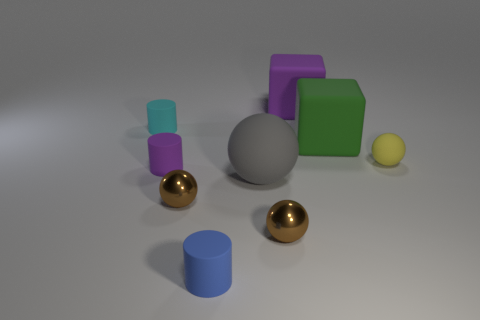There is a tiny sphere that is to the right of the matte block that is in front of the purple matte cube; what color is it?
Your answer should be compact. Yellow. How many large rubber objects are both to the right of the gray rubber ball and in front of the yellow ball?
Offer a terse response. 0. What number of gray matte objects have the same shape as the yellow thing?
Your answer should be compact. 1. Does the large green object have the same material as the big purple block?
Make the answer very short. Yes. There is a small matte object that is to the right of the cube that is in front of the tiny cyan rubber thing; what is its shape?
Offer a very short reply. Sphere. How many small matte balls are behind the yellow sphere that is behind the small purple rubber thing?
Ensure brevity in your answer.  0. What is the tiny sphere that is right of the big sphere and left of the purple rubber block made of?
Offer a very short reply. Metal. What shape is the cyan thing that is the same size as the yellow thing?
Give a very brief answer. Cylinder. There is a small metallic ball that is on the right side of the matte ball that is to the left of the tiny ball that is on the right side of the large purple matte object; what color is it?
Provide a succinct answer. Brown. How many objects are tiny matte objects that are behind the large green block or purple cylinders?
Keep it short and to the point. 2. 